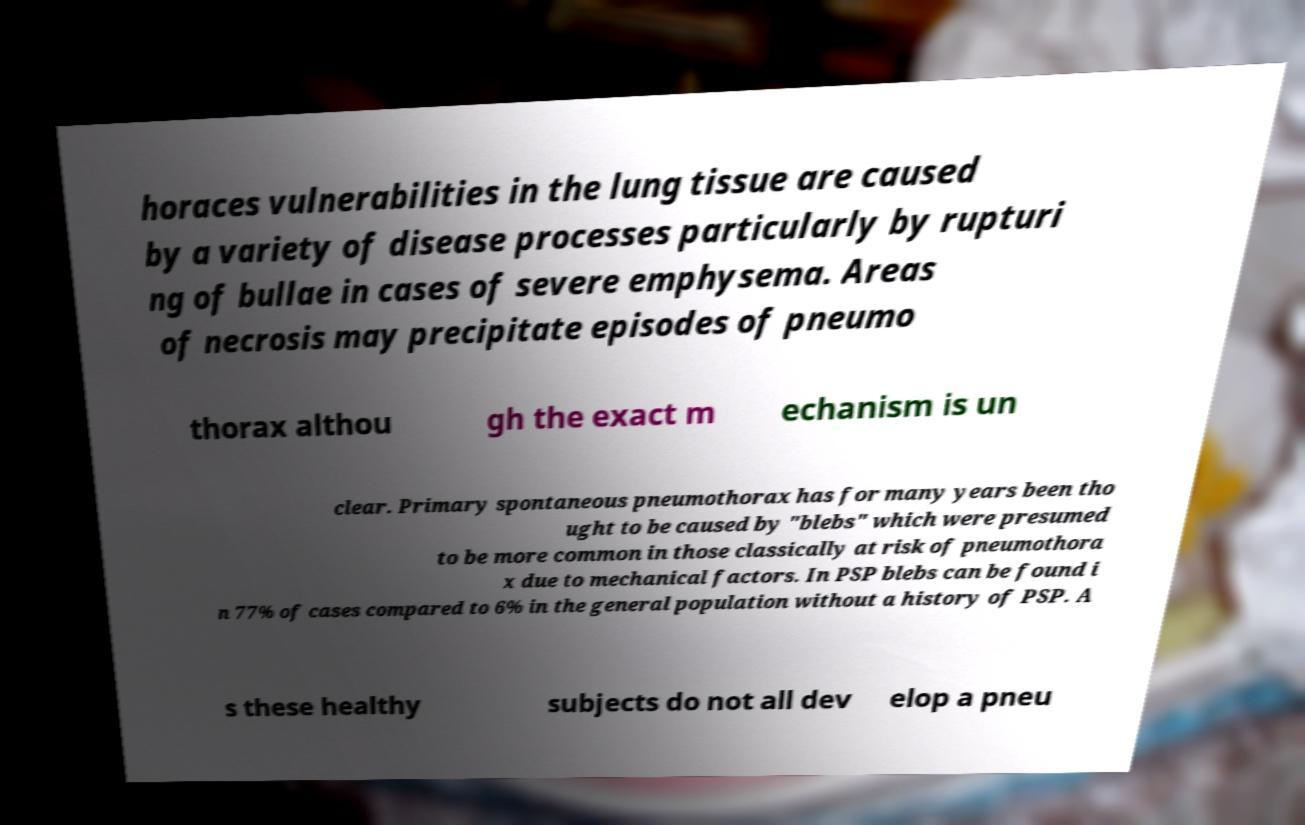For documentation purposes, I need the text within this image transcribed. Could you provide that? horaces vulnerabilities in the lung tissue are caused by a variety of disease processes particularly by rupturi ng of bullae in cases of severe emphysema. Areas of necrosis may precipitate episodes of pneumo thorax althou gh the exact m echanism is un clear. Primary spontaneous pneumothorax has for many years been tho ught to be caused by "blebs" which were presumed to be more common in those classically at risk of pneumothora x due to mechanical factors. In PSP blebs can be found i n 77% of cases compared to 6% in the general population without a history of PSP. A s these healthy subjects do not all dev elop a pneu 